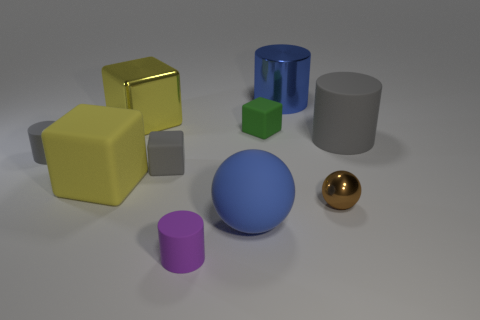Subtract all gray cubes. How many gray cylinders are left? 2 Subtract 1 blocks. How many blocks are left? 3 Subtract all red cylinders. Subtract all red cubes. How many cylinders are left? 4 Subtract all blocks. How many objects are left? 6 Add 8 tiny matte blocks. How many tiny matte blocks are left? 10 Add 1 small brown matte cylinders. How many small brown matte cylinders exist? 1 Subtract 0 red cylinders. How many objects are left? 10 Subtract all small gray cubes. Subtract all small purple metallic cylinders. How many objects are left? 9 